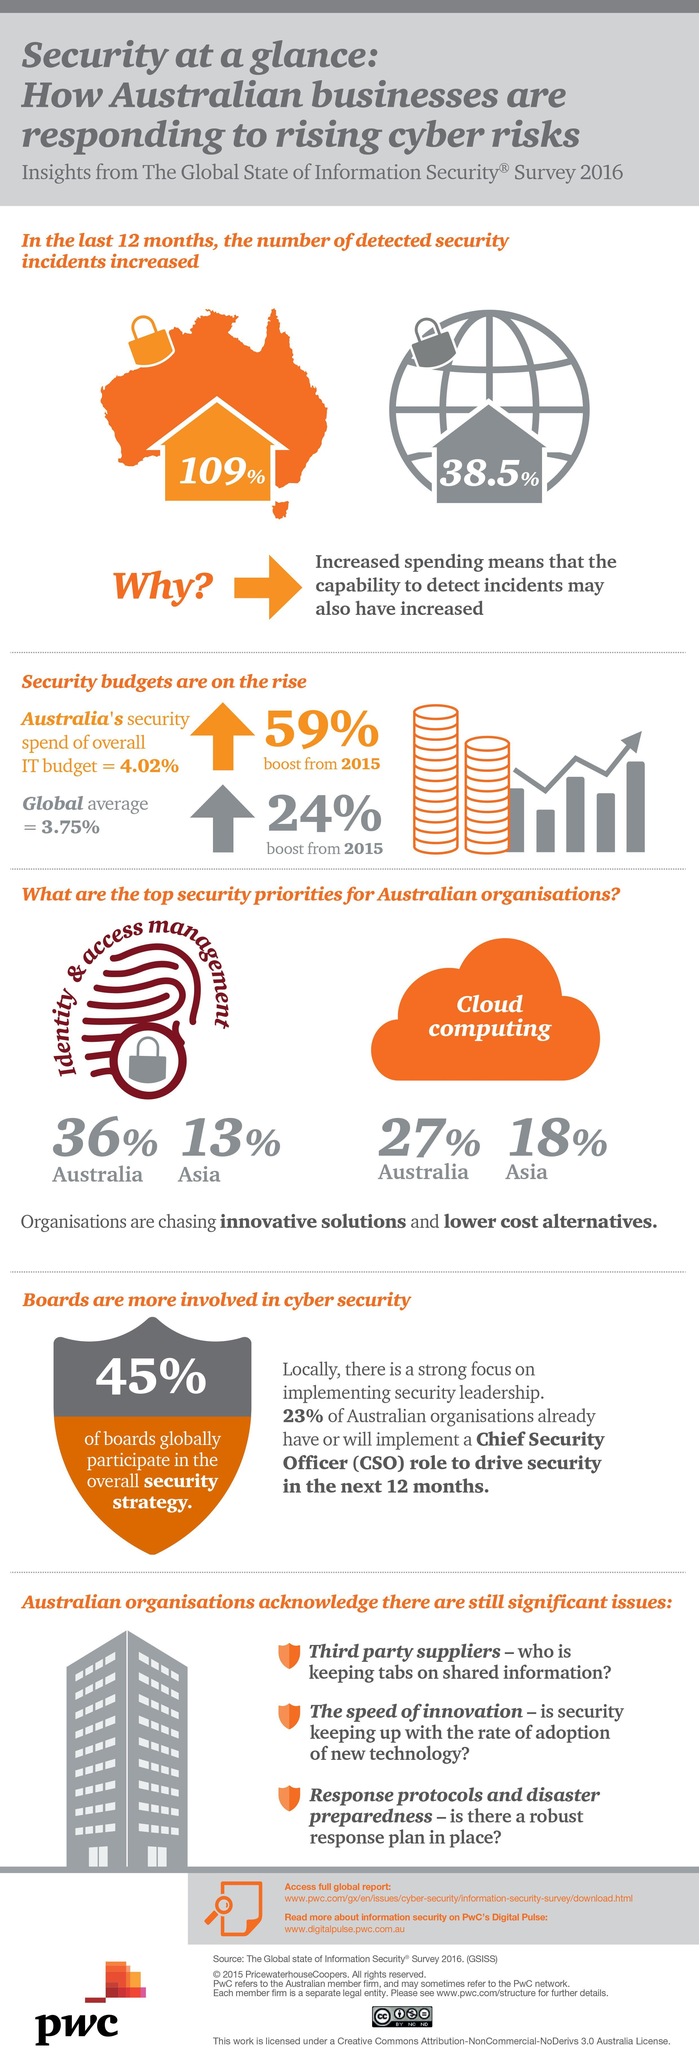What is the percentage difference of Australians and Asians opting for Identity & Access Management?
Answer the question with a short phrase. 23% What is the percentage difference of Australians and Asians opting for cloud computing? 9% Which are the top priorities in security for Australian companies? Identity & Access management, Cloud Computing 